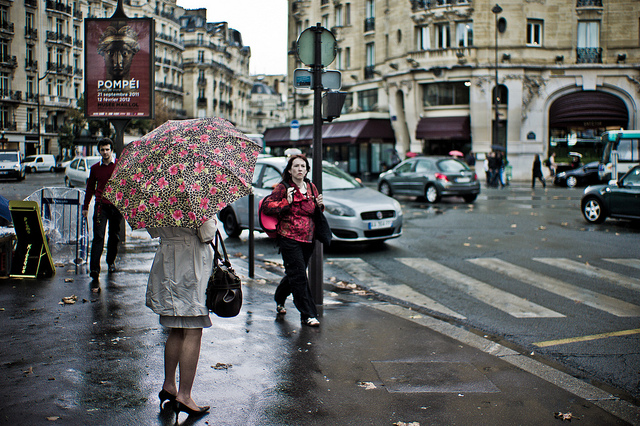Extract all visible text content from this image. POMPEI 